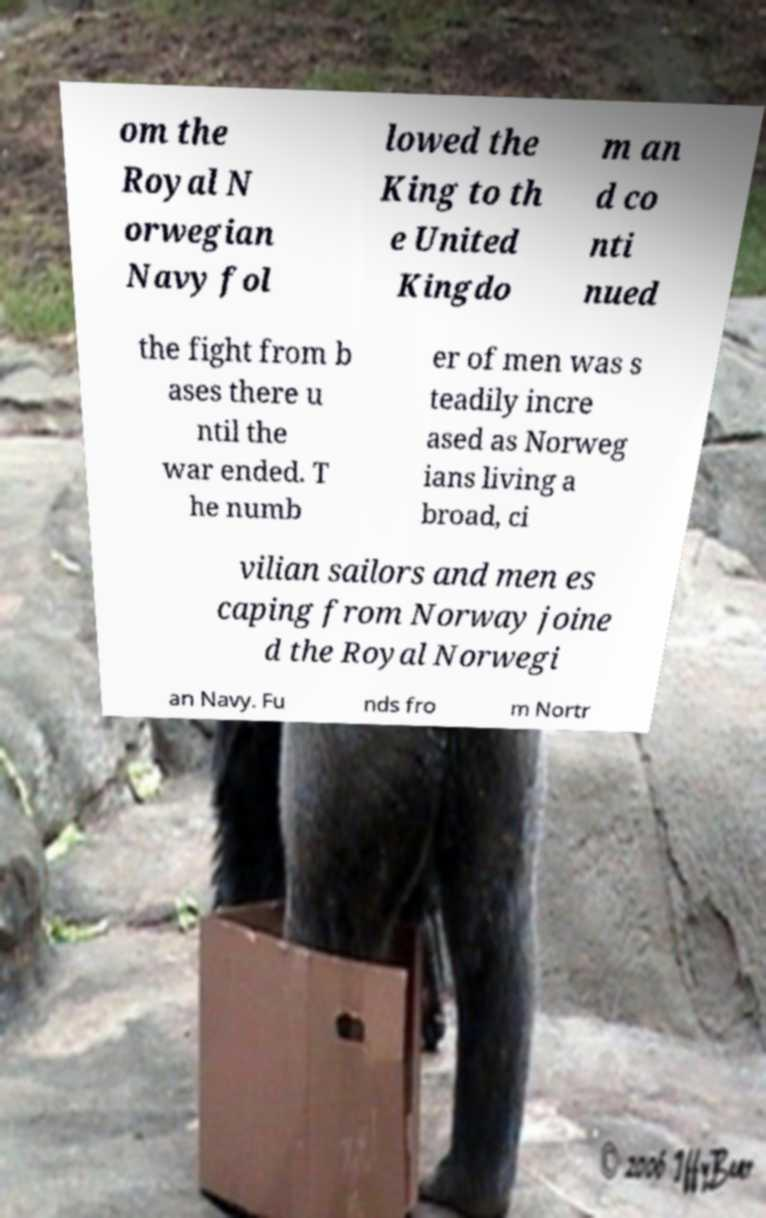There's text embedded in this image that I need extracted. Can you transcribe it verbatim? om the Royal N orwegian Navy fol lowed the King to th e United Kingdo m an d co nti nued the fight from b ases there u ntil the war ended. T he numb er of men was s teadily incre ased as Norweg ians living a broad, ci vilian sailors and men es caping from Norway joine d the Royal Norwegi an Navy. Fu nds fro m Nortr 